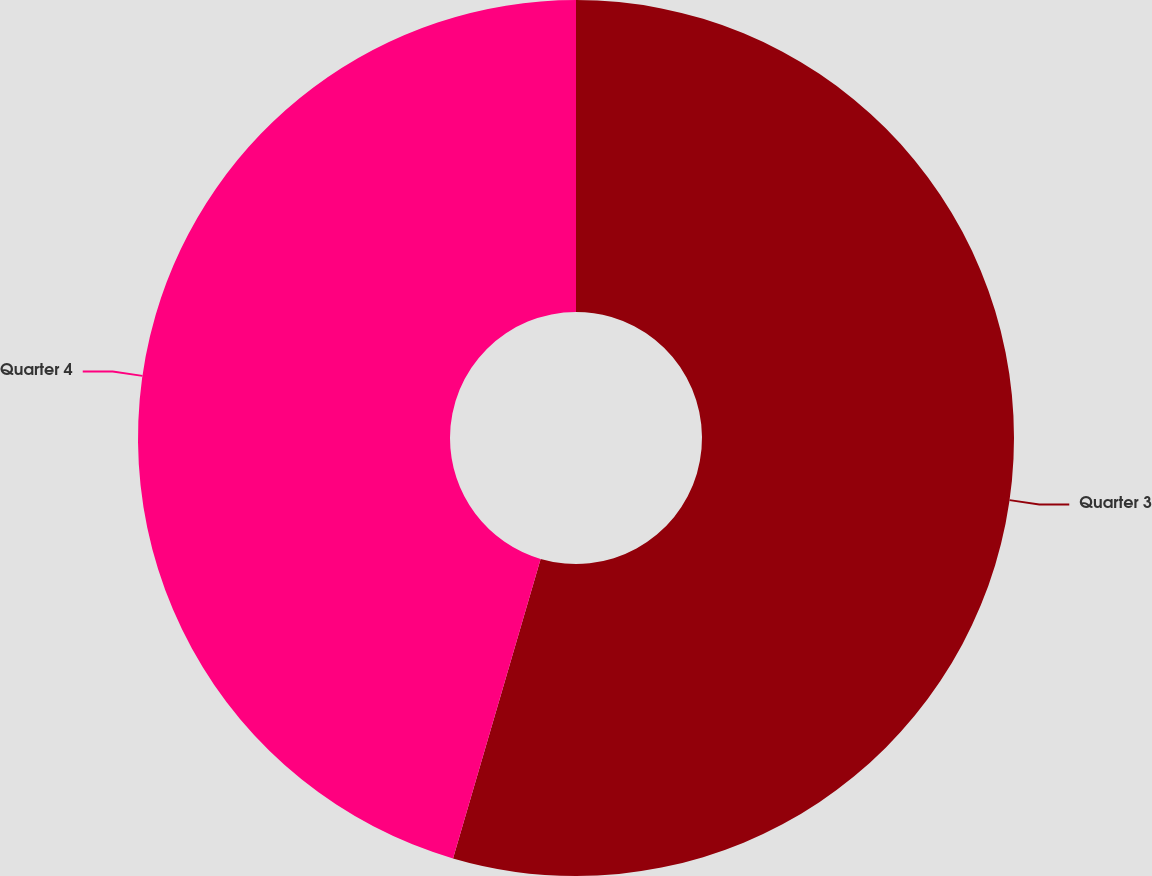Convert chart to OTSL. <chart><loc_0><loc_0><loc_500><loc_500><pie_chart><fcel>Quarter 3<fcel>Quarter 4<nl><fcel>54.53%<fcel>45.47%<nl></chart> 